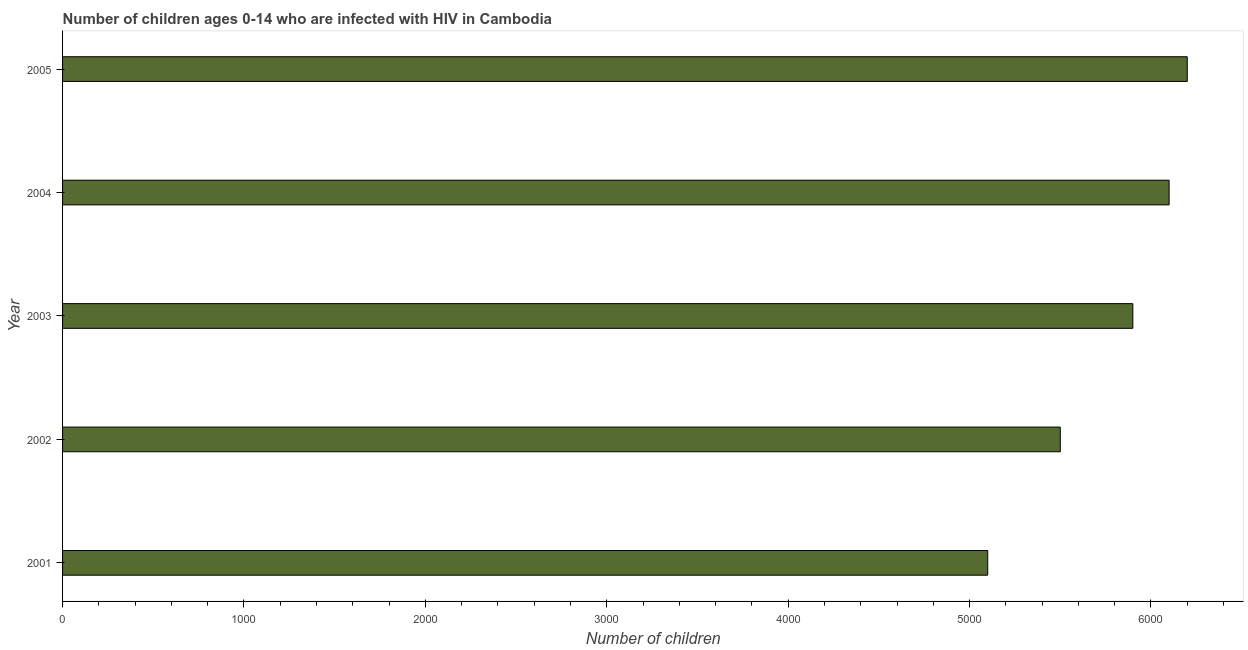Does the graph contain any zero values?
Your answer should be compact. No. Does the graph contain grids?
Keep it short and to the point. No. What is the title of the graph?
Your answer should be compact. Number of children ages 0-14 who are infected with HIV in Cambodia. What is the label or title of the X-axis?
Give a very brief answer. Number of children. What is the label or title of the Y-axis?
Provide a succinct answer. Year. What is the number of children living with hiv in 2003?
Your answer should be compact. 5900. Across all years, what is the maximum number of children living with hiv?
Provide a short and direct response. 6200. Across all years, what is the minimum number of children living with hiv?
Offer a very short reply. 5100. What is the sum of the number of children living with hiv?
Make the answer very short. 2.88e+04. What is the difference between the number of children living with hiv in 2001 and 2002?
Ensure brevity in your answer.  -400. What is the average number of children living with hiv per year?
Provide a succinct answer. 5760. What is the median number of children living with hiv?
Offer a terse response. 5900. Do a majority of the years between 2002 and 2004 (inclusive) have number of children living with hiv greater than 1000 ?
Provide a succinct answer. Yes. What is the ratio of the number of children living with hiv in 2002 to that in 2004?
Your response must be concise. 0.9. Is the number of children living with hiv in 2003 less than that in 2004?
Ensure brevity in your answer.  Yes. Is the sum of the number of children living with hiv in 2004 and 2005 greater than the maximum number of children living with hiv across all years?
Offer a terse response. Yes. What is the difference between the highest and the lowest number of children living with hiv?
Offer a terse response. 1100. How many bars are there?
Provide a succinct answer. 5. How many years are there in the graph?
Provide a succinct answer. 5. What is the Number of children of 2001?
Offer a very short reply. 5100. What is the Number of children of 2002?
Keep it short and to the point. 5500. What is the Number of children of 2003?
Ensure brevity in your answer.  5900. What is the Number of children in 2004?
Your response must be concise. 6100. What is the Number of children of 2005?
Offer a terse response. 6200. What is the difference between the Number of children in 2001 and 2002?
Provide a succinct answer. -400. What is the difference between the Number of children in 2001 and 2003?
Your answer should be very brief. -800. What is the difference between the Number of children in 2001 and 2004?
Offer a very short reply. -1000. What is the difference between the Number of children in 2001 and 2005?
Your answer should be very brief. -1100. What is the difference between the Number of children in 2002 and 2003?
Offer a terse response. -400. What is the difference between the Number of children in 2002 and 2004?
Your answer should be very brief. -600. What is the difference between the Number of children in 2002 and 2005?
Offer a very short reply. -700. What is the difference between the Number of children in 2003 and 2004?
Your answer should be compact. -200. What is the difference between the Number of children in 2003 and 2005?
Offer a terse response. -300. What is the difference between the Number of children in 2004 and 2005?
Keep it short and to the point. -100. What is the ratio of the Number of children in 2001 to that in 2002?
Ensure brevity in your answer.  0.93. What is the ratio of the Number of children in 2001 to that in 2003?
Your response must be concise. 0.86. What is the ratio of the Number of children in 2001 to that in 2004?
Ensure brevity in your answer.  0.84. What is the ratio of the Number of children in 2001 to that in 2005?
Keep it short and to the point. 0.82. What is the ratio of the Number of children in 2002 to that in 2003?
Provide a succinct answer. 0.93. What is the ratio of the Number of children in 2002 to that in 2004?
Give a very brief answer. 0.9. What is the ratio of the Number of children in 2002 to that in 2005?
Offer a very short reply. 0.89. What is the ratio of the Number of children in 2003 to that in 2004?
Keep it short and to the point. 0.97. What is the ratio of the Number of children in 2003 to that in 2005?
Your answer should be very brief. 0.95. What is the ratio of the Number of children in 2004 to that in 2005?
Your response must be concise. 0.98. 